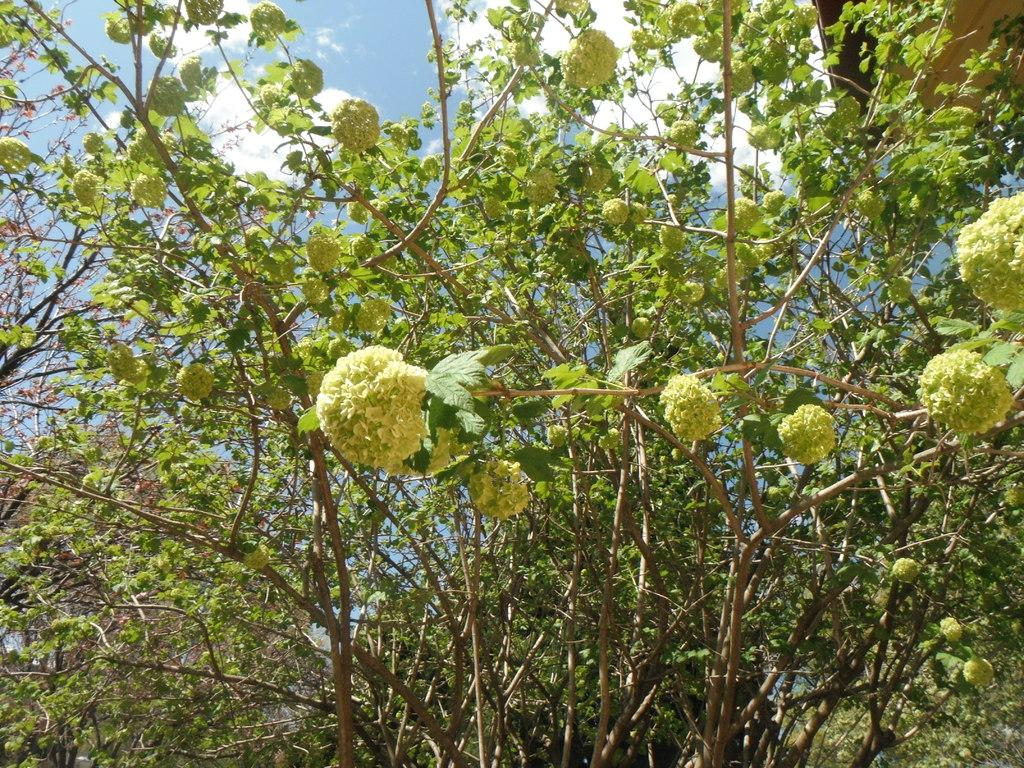What type of plant is visible in the image? There are flowers on a plant in the image. What is the condition of the sky in the image? The sky is blue and cloudy in the image. What type of humor is displayed on the badge in the image? There is no badge present in the image, so it is not possible to determine what type of humor might be displayed on it. 